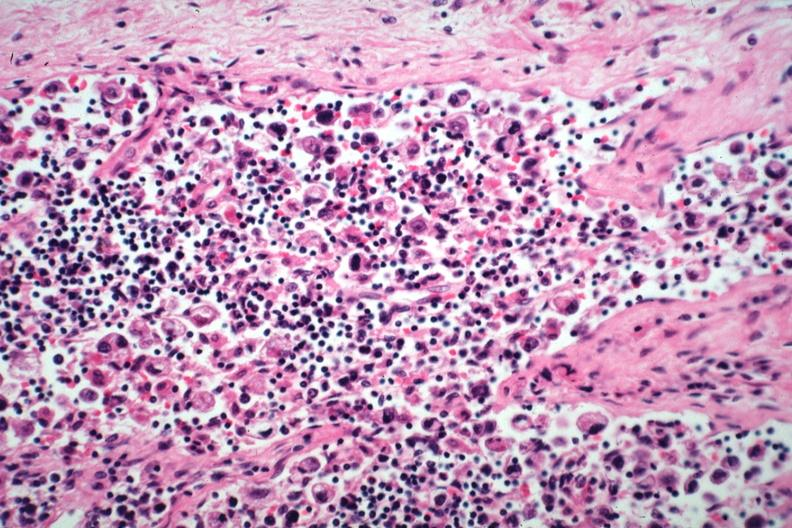s metastatic carcinoma present?
Answer the question using a single word or phrase. Yes 